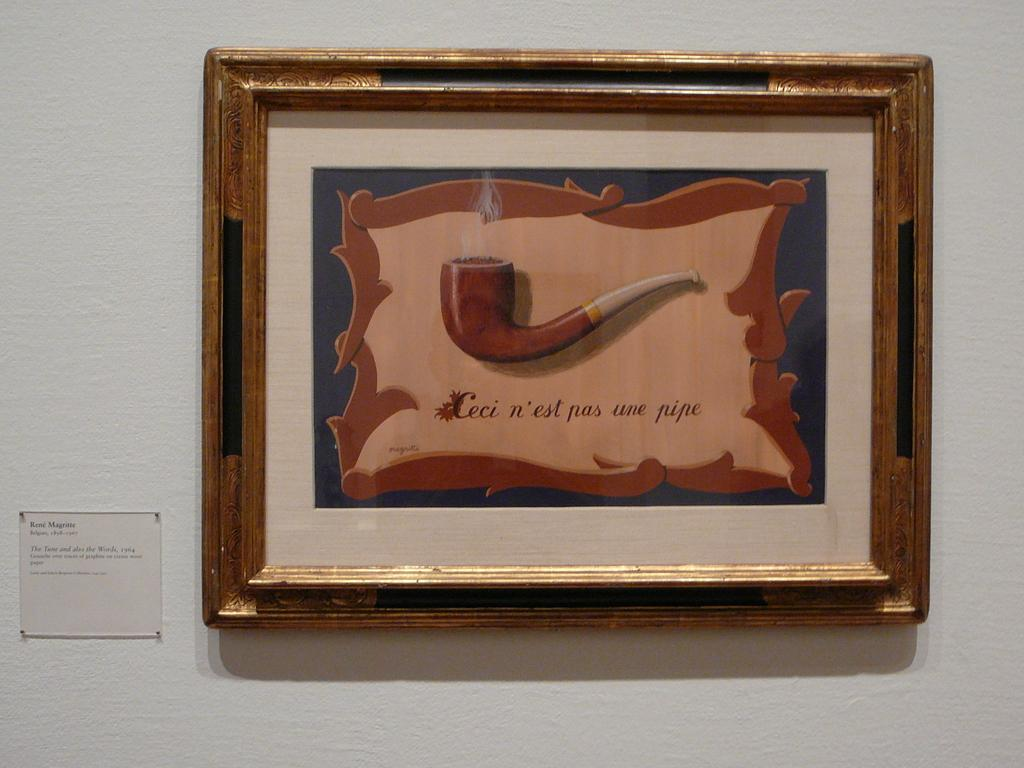<image>
Write a terse but informative summary of the picture. A print of a pipe has the caption Ceci n'est pas une pipe. 